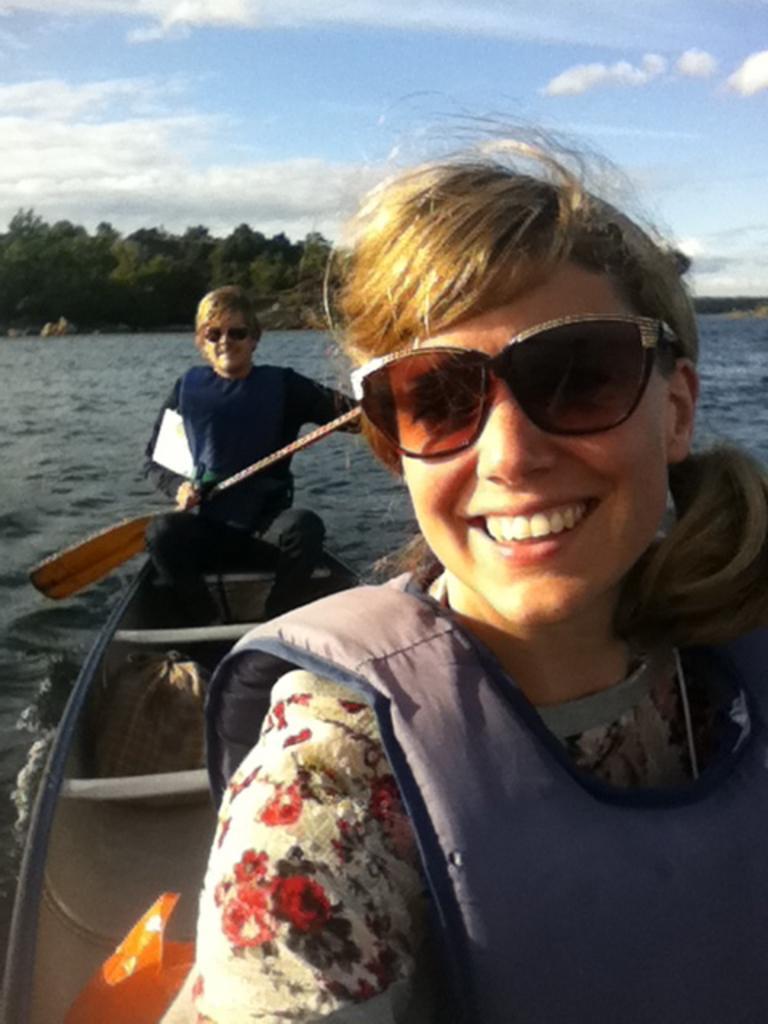Please provide a concise description of this image. In the image we can see a woman on the right side of the image and the woman is wearing clothes, life jacket, goggles and she is smiling. Behind her there is a person, sitting in the boat, wearing clothes, goggles and holding the paddles. Here we can water, trees and the cloudy sky. 